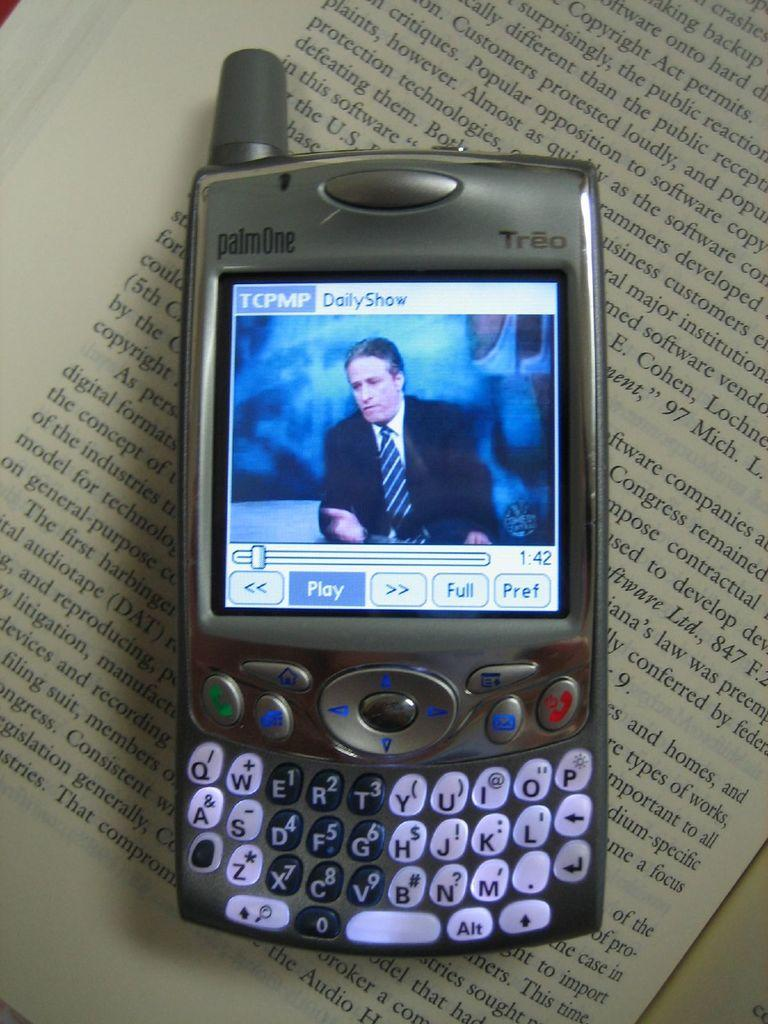What is the main object in the image? There is a book in the image. What is attached to the book? There is a mobile on the book. What is the mobile displaying? The mobile is displaying a video. What type of written content can be seen in the image? There is text on a paper in the image. Can you see the ocean in the background of the image? There is no ocean visible in the image; it features a book with a mobile displaying a video. 